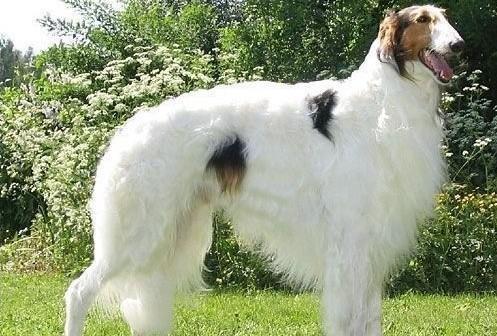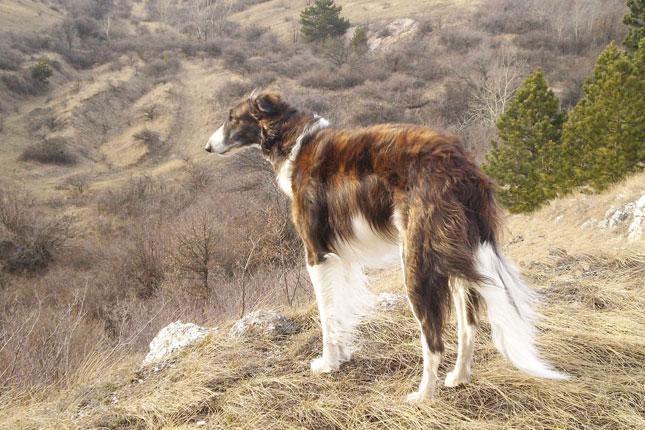The first image is the image on the left, the second image is the image on the right. Examine the images to the left and right. Is the description "Two dogs are pictured facing each other." accurate? Answer yes or no. Yes. 